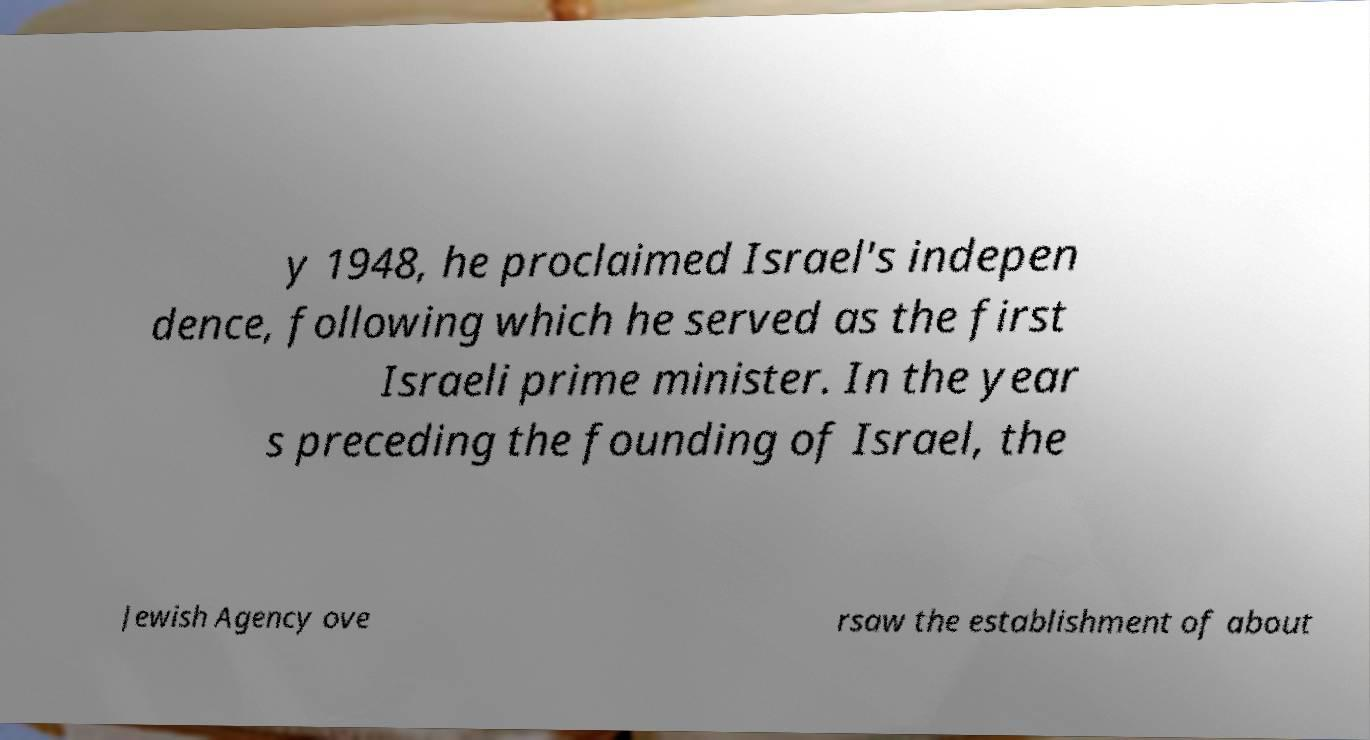There's text embedded in this image that I need extracted. Can you transcribe it verbatim? y 1948, he proclaimed Israel's indepen dence, following which he served as the first Israeli prime minister. In the year s preceding the founding of Israel, the Jewish Agency ove rsaw the establishment of about 